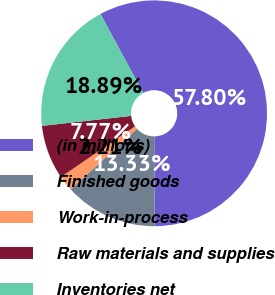Convert chart. <chart><loc_0><loc_0><loc_500><loc_500><pie_chart><fcel>(in millions)<fcel>Finished goods<fcel>Work-in-process<fcel>Raw materials and supplies<fcel>Inventories net<nl><fcel>57.8%<fcel>13.33%<fcel>2.21%<fcel>7.77%<fcel>18.89%<nl></chart> 